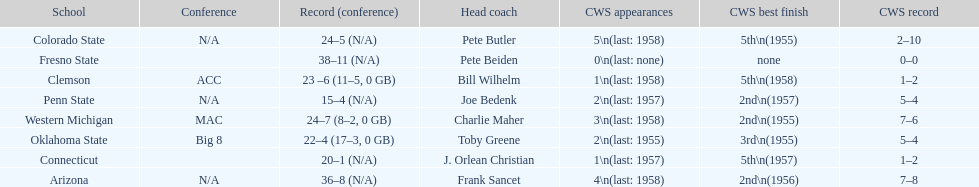Which school has no cws appearances? Fresno State. 